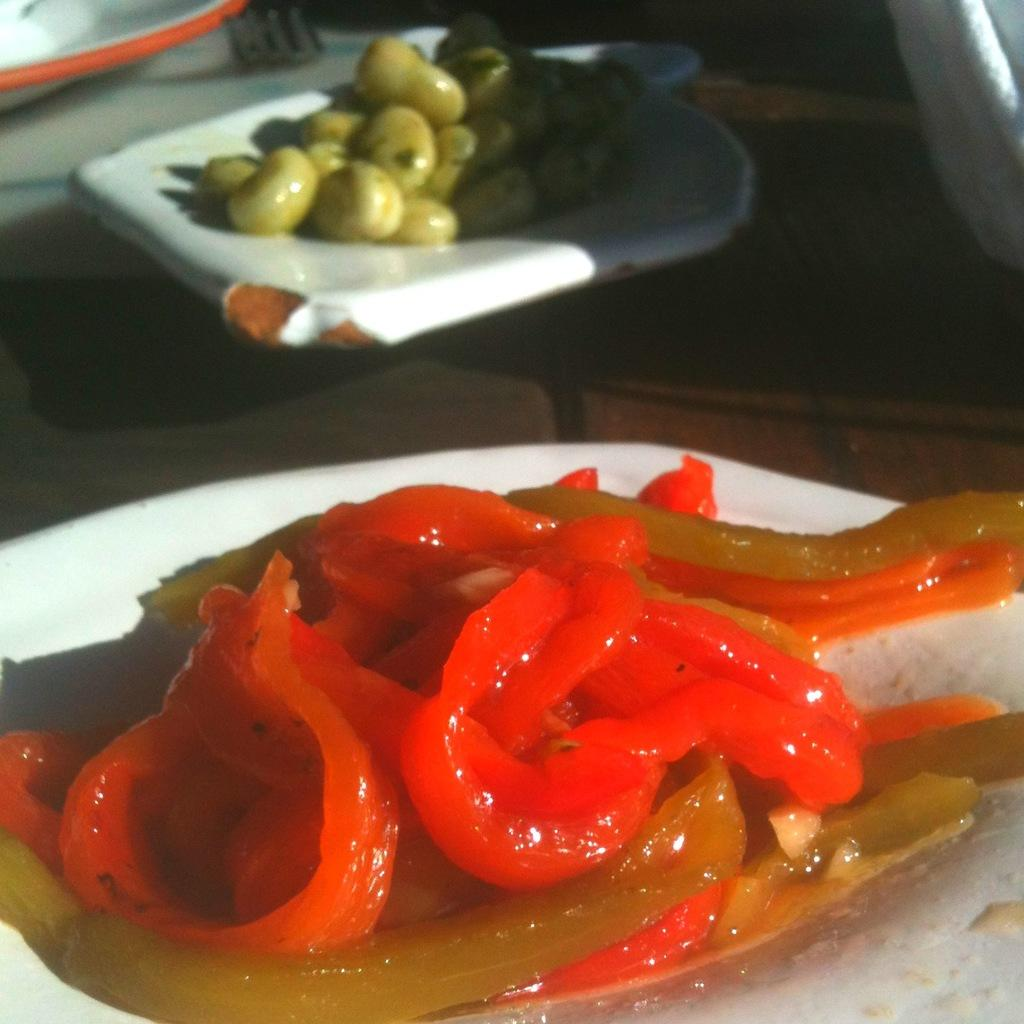What can be seen in the image in terms of food items? There are different types of food items placed in one place in the image. Can you describe the arrangement of the food items? Unfortunately, the facts provided do not give enough information to describe the arrangement of the food items. What types of food items can be seen in the image? The facts provided do not specify the types of food items present in the image. How many buildings can be seen in the image? There is no mention of buildings in the image, as the facts provided only mention food items. 